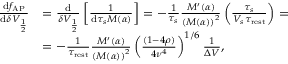<formula> <loc_0><loc_0><loc_500><loc_500>\begin{array} { r l } { \frac { d f _ { A P } } { d \delta V _ { \frac { 1 } { 2 } } } } & { = \frac { d } { \delta V _ { \frac { 1 } { 2 } } } \left [ \frac { 1 } { d \tau _ { s } M ( \alpha ) } \right ] = - \frac { 1 } { \tau _ { s } } \frac { M ^ { \prime } ( \alpha ) } { \left ( M ( \alpha ) \right ) ^ { 2 } } \left ( \frac { \tau _ { s } } { V _ { s } \tau _ { r e s t } } \right ) = } \\ & { = - \frac { 1 } { \tau _ { r e s t } } \frac { M ^ { \prime } ( \alpha ) } { \left ( M ( \alpha ) \right ) ^ { 2 } } \left ( \frac { ( 1 - 4 \rho ) } { 4 \nu ^ { 4 } } \right ) ^ { 1 / 6 } \frac { 1 } { \Delta V } , } \end{array}</formula> 